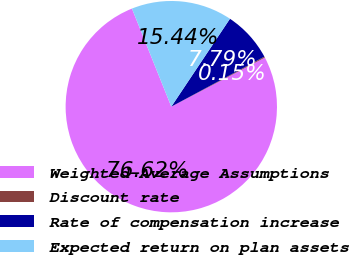Convert chart to OTSL. <chart><loc_0><loc_0><loc_500><loc_500><pie_chart><fcel>Weighted-Average Assumptions<fcel>Discount rate<fcel>Rate of compensation increase<fcel>Expected return on plan assets<nl><fcel>76.62%<fcel>0.15%<fcel>7.79%<fcel>15.44%<nl></chart> 